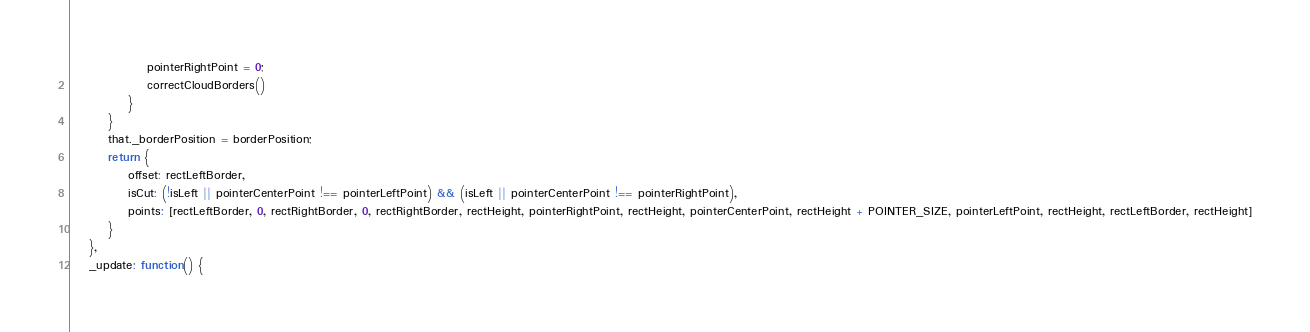Convert code to text. <code><loc_0><loc_0><loc_500><loc_500><_JavaScript_>                pointerRightPoint = 0;
                correctCloudBorders()
            }
        }
        that._borderPosition = borderPosition;
        return {
            offset: rectLeftBorder,
            isCut: (!isLeft || pointerCenterPoint !== pointerLeftPoint) && (isLeft || pointerCenterPoint !== pointerRightPoint),
            points: [rectLeftBorder, 0, rectRightBorder, 0, rectRightBorder, rectHeight, pointerRightPoint, rectHeight, pointerCenterPoint, rectHeight + POINTER_SIZE, pointerLeftPoint, rectHeight, rectLeftBorder, rectHeight]
        }
    },
    _update: function() {</code> 